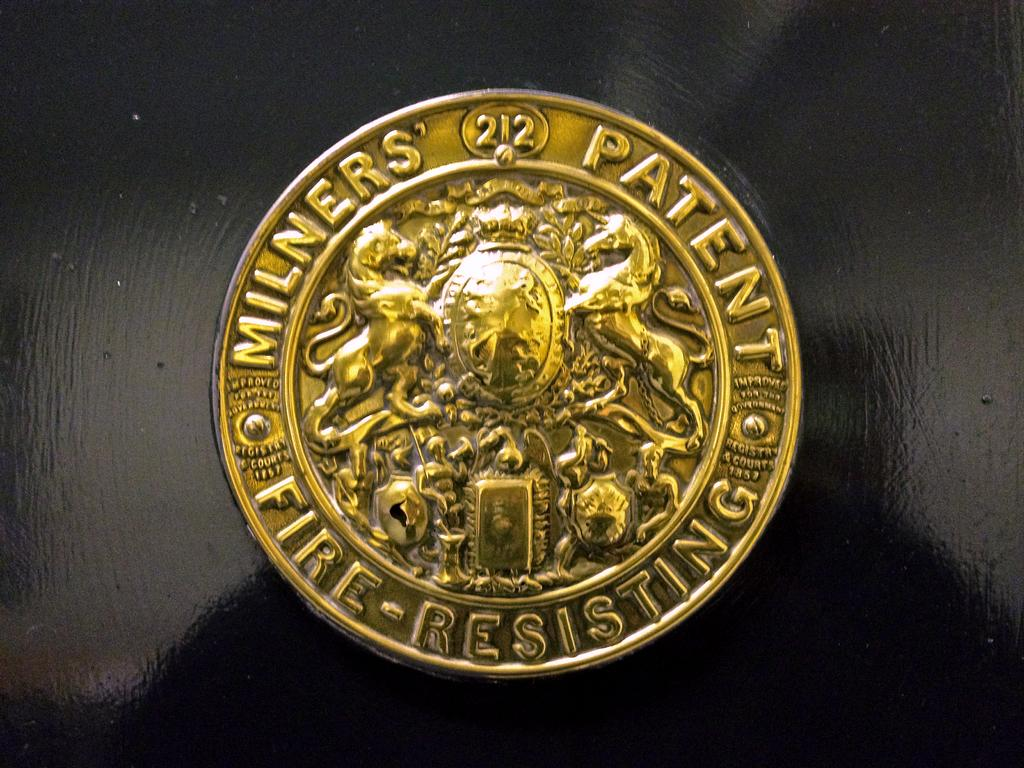<image>
Relay a brief, clear account of the picture shown. A gold button with Milners' Patent Fire Resistant on it. 